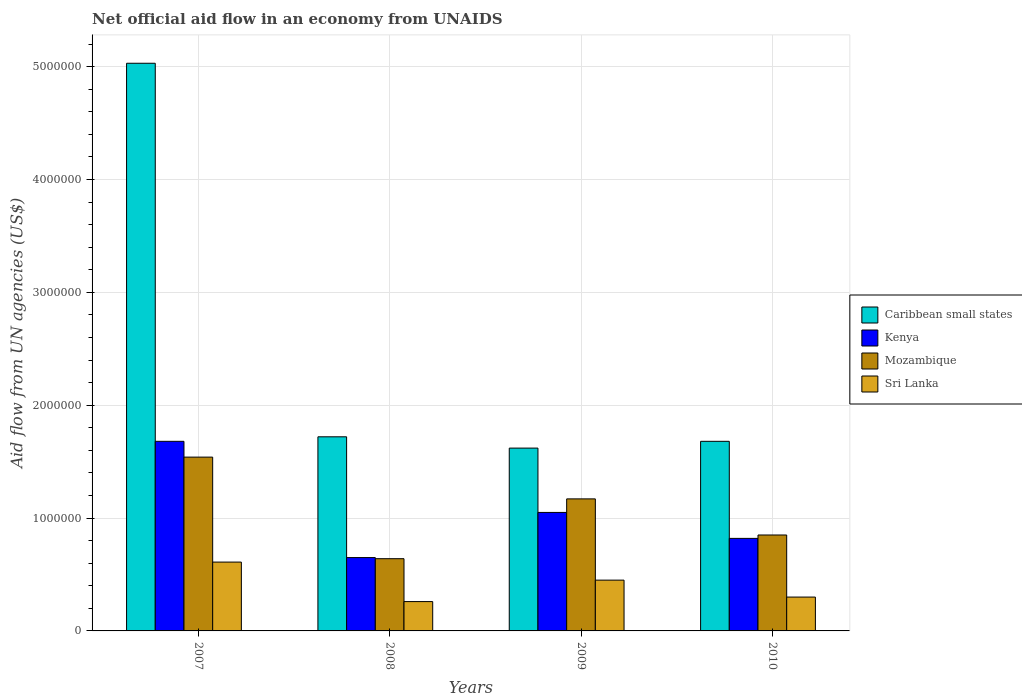Are the number of bars per tick equal to the number of legend labels?
Make the answer very short. Yes. Are the number of bars on each tick of the X-axis equal?
Offer a very short reply. Yes. How many bars are there on the 2nd tick from the left?
Ensure brevity in your answer.  4. In how many cases, is the number of bars for a given year not equal to the number of legend labels?
Provide a succinct answer. 0. What is the net official aid flow in Mozambique in 2009?
Ensure brevity in your answer.  1.17e+06. Across all years, what is the maximum net official aid flow in Mozambique?
Make the answer very short. 1.54e+06. Across all years, what is the minimum net official aid flow in Mozambique?
Keep it short and to the point. 6.40e+05. In which year was the net official aid flow in Kenya minimum?
Provide a short and direct response. 2008. What is the total net official aid flow in Sri Lanka in the graph?
Your answer should be very brief. 1.62e+06. What is the difference between the net official aid flow in Caribbean small states in 2007 and that in 2010?
Your response must be concise. 3.35e+06. What is the average net official aid flow in Caribbean small states per year?
Keep it short and to the point. 2.51e+06. In the year 2007, what is the difference between the net official aid flow in Sri Lanka and net official aid flow in Kenya?
Your answer should be compact. -1.07e+06. In how many years, is the net official aid flow in Kenya greater than 1000000 US$?
Your answer should be compact. 2. What is the ratio of the net official aid flow in Kenya in 2008 to that in 2009?
Your response must be concise. 0.62. What is the difference between the highest and the second highest net official aid flow in Caribbean small states?
Ensure brevity in your answer.  3.31e+06. What is the difference between the highest and the lowest net official aid flow in Mozambique?
Keep it short and to the point. 9.00e+05. Is the sum of the net official aid flow in Caribbean small states in 2007 and 2010 greater than the maximum net official aid flow in Sri Lanka across all years?
Provide a short and direct response. Yes. What does the 2nd bar from the left in 2007 represents?
Your answer should be very brief. Kenya. What does the 1st bar from the right in 2008 represents?
Give a very brief answer. Sri Lanka. Are all the bars in the graph horizontal?
Keep it short and to the point. No. How many years are there in the graph?
Give a very brief answer. 4. How are the legend labels stacked?
Keep it short and to the point. Vertical. What is the title of the graph?
Your answer should be compact. Net official aid flow in an economy from UNAIDS. Does "Sao Tome and Principe" appear as one of the legend labels in the graph?
Ensure brevity in your answer.  No. What is the label or title of the X-axis?
Your answer should be very brief. Years. What is the label or title of the Y-axis?
Your answer should be very brief. Aid flow from UN agencies (US$). What is the Aid flow from UN agencies (US$) in Caribbean small states in 2007?
Ensure brevity in your answer.  5.03e+06. What is the Aid flow from UN agencies (US$) in Kenya in 2007?
Provide a short and direct response. 1.68e+06. What is the Aid flow from UN agencies (US$) in Mozambique in 2007?
Ensure brevity in your answer.  1.54e+06. What is the Aid flow from UN agencies (US$) in Sri Lanka in 2007?
Provide a short and direct response. 6.10e+05. What is the Aid flow from UN agencies (US$) in Caribbean small states in 2008?
Ensure brevity in your answer.  1.72e+06. What is the Aid flow from UN agencies (US$) in Kenya in 2008?
Make the answer very short. 6.50e+05. What is the Aid flow from UN agencies (US$) in Mozambique in 2008?
Offer a terse response. 6.40e+05. What is the Aid flow from UN agencies (US$) of Sri Lanka in 2008?
Provide a succinct answer. 2.60e+05. What is the Aid flow from UN agencies (US$) in Caribbean small states in 2009?
Offer a very short reply. 1.62e+06. What is the Aid flow from UN agencies (US$) in Kenya in 2009?
Your answer should be compact. 1.05e+06. What is the Aid flow from UN agencies (US$) in Mozambique in 2009?
Give a very brief answer. 1.17e+06. What is the Aid flow from UN agencies (US$) in Sri Lanka in 2009?
Keep it short and to the point. 4.50e+05. What is the Aid flow from UN agencies (US$) in Caribbean small states in 2010?
Provide a short and direct response. 1.68e+06. What is the Aid flow from UN agencies (US$) in Kenya in 2010?
Provide a short and direct response. 8.20e+05. What is the Aid flow from UN agencies (US$) of Mozambique in 2010?
Offer a very short reply. 8.50e+05. What is the Aid flow from UN agencies (US$) in Sri Lanka in 2010?
Your response must be concise. 3.00e+05. Across all years, what is the maximum Aid flow from UN agencies (US$) of Caribbean small states?
Your answer should be very brief. 5.03e+06. Across all years, what is the maximum Aid flow from UN agencies (US$) of Kenya?
Make the answer very short. 1.68e+06. Across all years, what is the maximum Aid flow from UN agencies (US$) in Mozambique?
Provide a short and direct response. 1.54e+06. Across all years, what is the maximum Aid flow from UN agencies (US$) of Sri Lanka?
Your answer should be compact. 6.10e+05. Across all years, what is the minimum Aid flow from UN agencies (US$) of Caribbean small states?
Make the answer very short. 1.62e+06. Across all years, what is the minimum Aid flow from UN agencies (US$) in Kenya?
Keep it short and to the point. 6.50e+05. Across all years, what is the minimum Aid flow from UN agencies (US$) in Mozambique?
Make the answer very short. 6.40e+05. Across all years, what is the minimum Aid flow from UN agencies (US$) of Sri Lanka?
Your answer should be very brief. 2.60e+05. What is the total Aid flow from UN agencies (US$) in Caribbean small states in the graph?
Offer a very short reply. 1.00e+07. What is the total Aid flow from UN agencies (US$) of Kenya in the graph?
Provide a short and direct response. 4.20e+06. What is the total Aid flow from UN agencies (US$) in Mozambique in the graph?
Your response must be concise. 4.20e+06. What is the total Aid flow from UN agencies (US$) in Sri Lanka in the graph?
Provide a succinct answer. 1.62e+06. What is the difference between the Aid flow from UN agencies (US$) of Caribbean small states in 2007 and that in 2008?
Keep it short and to the point. 3.31e+06. What is the difference between the Aid flow from UN agencies (US$) in Kenya in 2007 and that in 2008?
Ensure brevity in your answer.  1.03e+06. What is the difference between the Aid flow from UN agencies (US$) in Mozambique in 2007 and that in 2008?
Offer a terse response. 9.00e+05. What is the difference between the Aid flow from UN agencies (US$) of Caribbean small states in 2007 and that in 2009?
Provide a short and direct response. 3.41e+06. What is the difference between the Aid flow from UN agencies (US$) of Kenya in 2007 and that in 2009?
Offer a terse response. 6.30e+05. What is the difference between the Aid flow from UN agencies (US$) in Mozambique in 2007 and that in 2009?
Your answer should be very brief. 3.70e+05. What is the difference between the Aid flow from UN agencies (US$) in Caribbean small states in 2007 and that in 2010?
Ensure brevity in your answer.  3.35e+06. What is the difference between the Aid flow from UN agencies (US$) of Kenya in 2007 and that in 2010?
Offer a very short reply. 8.60e+05. What is the difference between the Aid flow from UN agencies (US$) in Mozambique in 2007 and that in 2010?
Offer a terse response. 6.90e+05. What is the difference between the Aid flow from UN agencies (US$) of Caribbean small states in 2008 and that in 2009?
Offer a terse response. 1.00e+05. What is the difference between the Aid flow from UN agencies (US$) of Kenya in 2008 and that in 2009?
Ensure brevity in your answer.  -4.00e+05. What is the difference between the Aid flow from UN agencies (US$) of Mozambique in 2008 and that in 2009?
Ensure brevity in your answer.  -5.30e+05. What is the difference between the Aid flow from UN agencies (US$) of Caribbean small states in 2008 and that in 2010?
Keep it short and to the point. 4.00e+04. What is the difference between the Aid flow from UN agencies (US$) of Kenya in 2008 and that in 2010?
Provide a short and direct response. -1.70e+05. What is the difference between the Aid flow from UN agencies (US$) of Mozambique in 2008 and that in 2010?
Your response must be concise. -2.10e+05. What is the difference between the Aid flow from UN agencies (US$) in Caribbean small states in 2009 and that in 2010?
Make the answer very short. -6.00e+04. What is the difference between the Aid flow from UN agencies (US$) of Mozambique in 2009 and that in 2010?
Your answer should be very brief. 3.20e+05. What is the difference between the Aid flow from UN agencies (US$) of Caribbean small states in 2007 and the Aid flow from UN agencies (US$) of Kenya in 2008?
Keep it short and to the point. 4.38e+06. What is the difference between the Aid flow from UN agencies (US$) of Caribbean small states in 2007 and the Aid flow from UN agencies (US$) of Mozambique in 2008?
Your response must be concise. 4.39e+06. What is the difference between the Aid flow from UN agencies (US$) in Caribbean small states in 2007 and the Aid flow from UN agencies (US$) in Sri Lanka in 2008?
Make the answer very short. 4.77e+06. What is the difference between the Aid flow from UN agencies (US$) of Kenya in 2007 and the Aid flow from UN agencies (US$) of Mozambique in 2008?
Ensure brevity in your answer.  1.04e+06. What is the difference between the Aid flow from UN agencies (US$) of Kenya in 2007 and the Aid flow from UN agencies (US$) of Sri Lanka in 2008?
Ensure brevity in your answer.  1.42e+06. What is the difference between the Aid flow from UN agencies (US$) of Mozambique in 2007 and the Aid flow from UN agencies (US$) of Sri Lanka in 2008?
Your answer should be very brief. 1.28e+06. What is the difference between the Aid flow from UN agencies (US$) in Caribbean small states in 2007 and the Aid flow from UN agencies (US$) in Kenya in 2009?
Keep it short and to the point. 3.98e+06. What is the difference between the Aid flow from UN agencies (US$) in Caribbean small states in 2007 and the Aid flow from UN agencies (US$) in Mozambique in 2009?
Offer a very short reply. 3.86e+06. What is the difference between the Aid flow from UN agencies (US$) of Caribbean small states in 2007 and the Aid flow from UN agencies (US$) of Sri Lanka in 2009?
Ensure brevity in your answer.  4.58e+06. What is the difference between the Aid flow from UN agencies (US$) of Kenya in 2007 and the Aid flow from UN agencies (US$) of Mozambique in 2009?
Make the answer very short. 5.10e+05. What is the difference between the Aid flow from UN agencies (US$) in Kenya in 2007 and the Aid flow from UN agencies (US$) in Sri Lanka in 2009?
Keep it short and to the point. 1.23e+06. What is the difference between the Aid flow from UN agencies (US$) of Mozambique in 2007 and the Aid flow from UN agencies (US$) of Sri Lanka in 2009?
Offer a terse response. 1.09e+06. What is the difference between the Aid flow from UN agencies (US$) in Caribbean small states in 2007 and the Aid flow from UN agencies (US$) in Kenya in 2010?
Offer a very short reply. 4.21e+06. What is the difference between the Aid flow from UN agencies (US$) of Caribbean small states in 2007 and the Aid flow from UN agencies (US$) of Mozambique in 2010?
Offer a very short reply. 4.18e+06. What is the difference between the Aid flow from UN agencies (US$) of Caribbean small states in 2007 and the Aid flow from UN agencies (US$) of Sri Lanka in 2010?
Keep it short and to the point. 4.73e+06. What is the difference between the Aid flow from UN agencies (US$) of Kenya in 2007 and the Aid flow from UN agencies (US$) of Mozambique in 2010?
Provide a succinct answer. 8.30e+05. What is the difference between the Aid flow from UN agencies (US$) in Kenya in 2007 and the Aid flow from UN agencies (US$) in Sri Lanka in 2010?
Your answer should be compact. 1.38e+06. What is the difference between the Aid flow from UN agencies (US$) in Mozambique in 2007 and the Aid flow from UN agencies (US$) in Sri Lanka in 2010?
Your response must be concise. 1.24e+06. What is the difference between the Aid flow from UN agencies (US$) of Caribbean small states in 2008 and the Aid flow from UN agencies (US$) of Kenya in 2009?
Provide a short and direct response. 6.70e+05. What is the difference between the Aid flow from UN agencies (US$) in Caribbean small states in 2008 and the Aid flow from UN agencies (US$) in Sri Lanka in 2009?
Offer a very short reply. 1.27e+06. What is the difference between the Aid flow from UN agencies (US$) in Kenya in 2008 and the Aid flow from UN agencies (US$) in Mozambique in 2009?
Make the answer very short. -5.20e+05. What is the difference between the Aid flow from UN agencies (US$) in Kenya in 2008 and the Aid flow from UN agencies (US$) in Sri Lanka in 2009?
Provide a short and direct response. 2.00e+05. What is the difference between the Aid flow from UN agencies (US$) in Caribbean small states in 2008 and the Aid flow from UN agencies (US$) in Mozambique in 2010?
Provide a short and direct response. 8.70e+05. What is the difference between the Aid flow from UN agencies (US$) of Caribbean small states in 2008 and the Aid flow from UN agencies (US$) of Sri Lanka in 2010?
Provide a short and direct response. 1.42e+06. What is the difference between the Aid flow from UN agencies (US$) in Kenya in 2008 and the Aid flow from UN agencies (US$) in Sri Lanka in 2010?
Keep it short and to the point. 3.50e+05. What is the difference between the Aid flow from UN agencies (US$) of Caribbean small states in 2009 and the Aid flow from UN agencies (US$) of Kenya in 2010?
Give a very brief answer. 8.00e+05. What is the difference between the Aid flow from UN agencies (US$) of Caribbean small states in 2009 and the Aid flow from UN agencies (US$) of Mozambique in 2010?
Give a very brief answer. 7.70e+05. What is the difference between the Aid flow from UN agencies (US$) of Caribbean small states in 2009 and the Aid flow from UN agencies (US$) of Sri Lanka in 2010?
Provide a short and direct response. 1.32e+06. What is the difference between the Aid flow from UN agencies (US$) in Kenya in 2009 and the Aid flow from UN agencies (US$) in Sri Lanka in 2010?
Provide a short and direct response. 7.50e+05. What is the difference between the Aid flow from UN agencies (US$) of Mozambique in 2009 and the Aid flow from UN agencies (US$) of Sri Lanka in 2010?
Make the answer very short. 8.70e+05. What is the average Aid flow from UN agencies (US$) in Caribbean small states per year?
Offer a terse response. 2.51e+06. What is the average Aid flow from UN agencies (US$) in Kenya per year?
Give a very brief answer. 1.05e+06. What is the average Aid flow from UN agencies (US$) of Mozambique per year?
Give a very brief answer. 1.05e+06. What is the average Aid flow from UN agencies (US$) of Sri Lanka per year?
Your response must be concise. 4.05e+05. In the year 2007, what is the difference between the Aid flow from UN agencies (US$) in Caribbean small states and Aid flow from UN agencies (US$) in Kenya?
Provide a short and direct response. 3.35e+06. In the year 2007, what is the difference between the Aid flow from UN agencies (US$) of Caribbean small states and Aid flow from UN agencies (US$) of Mozambique?
Your answer should be very brief. 3.49e+06. In the year 2007, what is the difference between the Aid flow from UN agencies (US$) in Caribbean small states and Aid flow from UN agencies (US$) in Sri Lanka?
Give a very brief answer. 4.42e+06. In the year 2007, what is the difference between the Aid flow from UN agencies (US$) of Kenya and Aid flow from UN agencies (US$) of Sri Lanka?
Provide a short and direct response. 1.07e+06. In the year 2007, what is the difference between the Aid flow from UN agencies (US$) of Mozambique and Aid flow from UN agencies (US$) of Sri Lanka?
Ensure brevity in your answer.  9.30e+05. In the year 2008, what is the difference between the Aid flow from UN agencies (US$) in Caribbean small states and Aid flow from UN agencies (US$) in Kenya?
Your response must be concise. 1.07e+06. In the year 2008, what is the difference between the Aid flow from UN agencies (US$) of Caribbean small states and Aid flow from UN agencies (US$) of Mozambique?
Your response must be concise. 1.08e+06. In the year 2008, what is the difference between the Aid flow from UN agencies (US$) of Caribbean small states and Aid flow from UN agencies (US$) of Sri Lanka?
Make the answer very short. 1.46e+06. In the year 2008, what is the difference between the Aid flow from UN agencies (US$) of Kenya and Aid flow from UN agencies (US$) of Mozambique?
Your answer should be very brief. 10000. In the year 2008, what is the difference between the Aid flow from UN agencies (US$) of Kenya and Aid flow from UN agencies (US$) of Sri Lanka?
Keep it short and to the point. 3.90e+05. In the year 2008, what is the difference between the Aid flow from UN agencies (US$) in Mozambique and Aid flow from UN agencies (US$) in Sri Lanka?
Make the answer very short. 3.80e+05. In the year 2009, what is the difference between the Aid flow from UN agencies (US$) in Caribbean small states and Aid flow from UN agencies (US$) in Kenya?
Ensure brevity in your answer.  5.70e+05. In the year 2009, what is the difference between the Aid flow from UN agencies (US$) in Caribbean small states and Aid flow from UN agencies (US$) in Mozambique?
Keep it short and to the point. 4.50e+05. In the year 2009, what is the difference between the Aid flow from UN agencies (US$) of Caribbean small states and Aid flow from UN agencies (US$) of Sri Lanka?
Keep it short and to the point. 1.17e+06. In the year 2009, what is the difference between the Aid flow from UN agencies (US$) of Kenya and Aid flow from UN agencies (US$) of Sri Lanka?
Provide a short and direct response. 6.00e+05. In the year 2009, what is the difference between the Aid flow from UN agencies (US$) of Mozambique and Aid flow from UN agencies (US$) of Sri Lanka?
Your answer should be very brief. 7.20e+05. In the year 2010, what is the difference between the Aid flow from UN agencies (US$) of Caribbean small states and Aid flow from UN agencies (US$) of Kenya?
Provide a short and direct response. 8.60e+05. In the year 2010, what is the difference between the Aid flow from UN agencies (US$) of Caribbean small states and Aid flow from UN agencies (US$) of Mozambique?
Offer a very short reply. 8.30e+05. In the year 2010, what is the difference between the Aid flow from UN agencies (US$) in Caribbean small states and Aid flow from UN agencies (US$) in Sri Lanka?
Give a very brief answer. 1.38e+06. In the year 2010, what is the difference between the Aid flow from UN agencies (US$) in Kenya and Aid flow from UN agencies (US$) in Mozambique?
Make the answer very short. -3.00e+04. In the year 2010, what is the difference between the Aid flow from UN agencies (US$) in Kenya and Aid flow from UN agencies (US$) in Sri Lanka?
Provide a short and direct response. 5.20e+05. What is the ratio of the Aid flow from UN agencies (US$) in Caribbean small states in 2007 to that in 2008?
Ensure brevity in your answer.  2.92. What is the ratio of the Aid flow from UN agencies (US$) of Kenya in 2007 to that in 2008?
Your response must be concise. 2.58. What is the ratio of the Aid flow from UN agencies (US$) in Mozambique in 2007 to that in 2008?
Keep it short and to the point. 2.41. What is the ratio of the Aid flow from UN agencies (US$) in Sri Lanka in 2007 to that in 2008?
Your answer should be very brief. 2.35. What is the ratio of the Aid flow from UN agencies (US$) of Caribbean small states in 2007 to that in 2009?
Give a very brief answer. 3.1. What is the ratio of the Aid flow from UN agencies (US$) in Mozambique in 2007 to that in 2009?
Your answer should be very brief. 1.32. What is the ratio of the Aid flow from UN agencies (US$) in Sri Lanka in 2007 to that in 2009?
Keep it short and to the point. 1.36. What is the ratio of the Aid flow from UN agencies (US$) in Caribbean small states in 2007 to that in 2010?
Make the answer very short. 2.99. What is the ratio of the Aid flow from UN agencies (US$) in Kenya in 2007 to that in 2010?
Your response must be concise. 2.05. What is the ratio of the Aid flow from UN agencies (US$) of Mozambique in 2007 to that in 2010?
Ensure brevity in your answer.  1.81. What is the ratio of the Aid flow from UN agencies (US$) in Sri Lanka in 2007 to that in 2010?
Make the answer very short. 2.03. What is the ratio of the Aid flow from UN agencies (US$) of Caribbean small states in 2008 to that in 2009?
Provide a succinct answer. 1.06. What is the ratio of the Aid flow from UN agencies (US$) in Kenya in 2008 to that in 2009?
Ensure brevity in your answer.  0.62. What is the ratio of the Aid flow from UN agencies (US$) of Mozambique in 2008 to that in 2009?
Your answer should be very brief. 0.55. What is the ratio of the Aid flow from UN agencies (US$) of Sri Lanka in 2008 to that in 2009?
Keep it short and to the point. 0.58. What is the ratio of the Aid flow from UN agencies (US$) in Caribbean small states in 2008 to that in 2010?
Provide a succinct answer. 1.02. What is the ratio of the Aid flow from UN agencies (US$) in Kenya in 2008 to that in 2010?
Offer a terse response. 0.79. What is the ratio of the Aid flow from UN agencies (US$) in Mozambique in 2008 to that in 2010?
Provide a succinct answer. 0.75. What is the ratio of the Aid flow from UN agencies (US$) in Sri Lanka in 2008 to that in 2010?
Provide a short and direct response. 0.87. What is the ratio of the Aid flow from UN agencies (US$) of Caribbean small states in 2009 to that in 2010?
Ensure brevity in your answer.  0.96. What is the ratio of the Aid flow from UN agencies (US$) in Kenya in 2009 to that in 2010?
Provide a succinct answer. 1.28. What is the ratio of the Aid flow from UN agencies (US$) of Mozambique in 2009 to that in 2010?
Your answer should be very brief. 1.38. What is the ratio of the Aid flow from UN agencies (US$) of Sri Lanka in 2009 to that in 2010?
Offer a very short reply. 1.5. What is the difference between the highest and the second highest Aid flow from UN agencies (US$) in Caribbean small states?
Offer a very short reply. 3.31e+06. What is the difference between the highest and the second highest Aid flow from UN agencies (US$) in Kenya?
Keep it short and to the point. 6.30e+05. What is the difference between the highest and the second highest Aid flow from UN agencies (US$) of Mozambique?
Keep it short and to the point. 3.70e+05. What is the difference between the highest and the lowest Aid flow from UN agencies (US$) of Caribbean small states?
Your answer should be compact. 3.41e+06. What is the difference between the highest and the lowest Aid flow from UN agencies (US$) in Kenya?
Your response must be concise. 1.03e+06. What is the difference between the highest and the lowest Aid flow from UN agencies (US$) of Mozambique?
Offer a very short reply. 9.00e+05. What is the difference between the highest and the lowest Aid flow from UN agencies (US$) of Sri Lanka?
Your answer should be compact. 3.50e+05. 